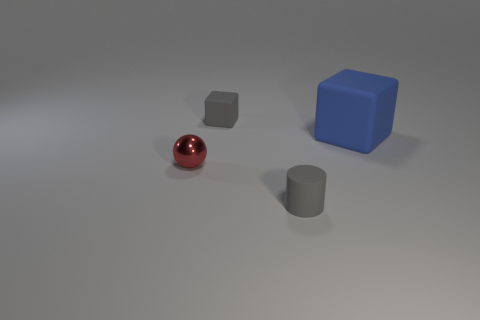Add 1 metallic spheres. How many objects exist? 5 Subtract all balls. How many objects are left? 3 Subtract 0 brown cylinders. How many objects are left? 4 Subtract all big matte blocks. Subtract all small cylinders. How many objects are left? 2 Add 3 small gray objects. How many small gray objects are left? 5 Add 4 tiny metal cylinders. How many tiny metal cylinders exist? 4 